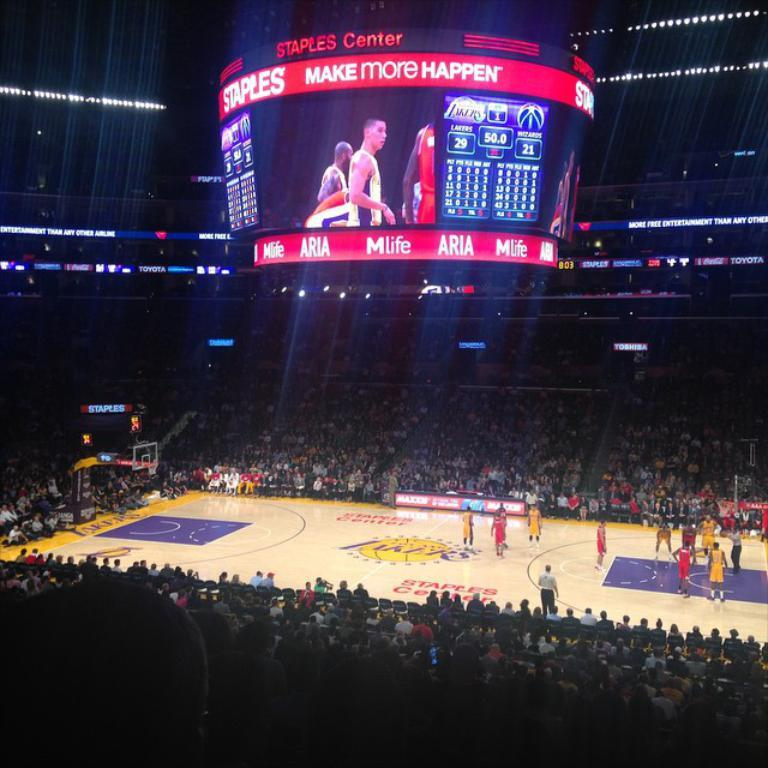<image>
Relay a brief, clear account of the picture shown. A basketball game being played in a stadium built by Staples. 